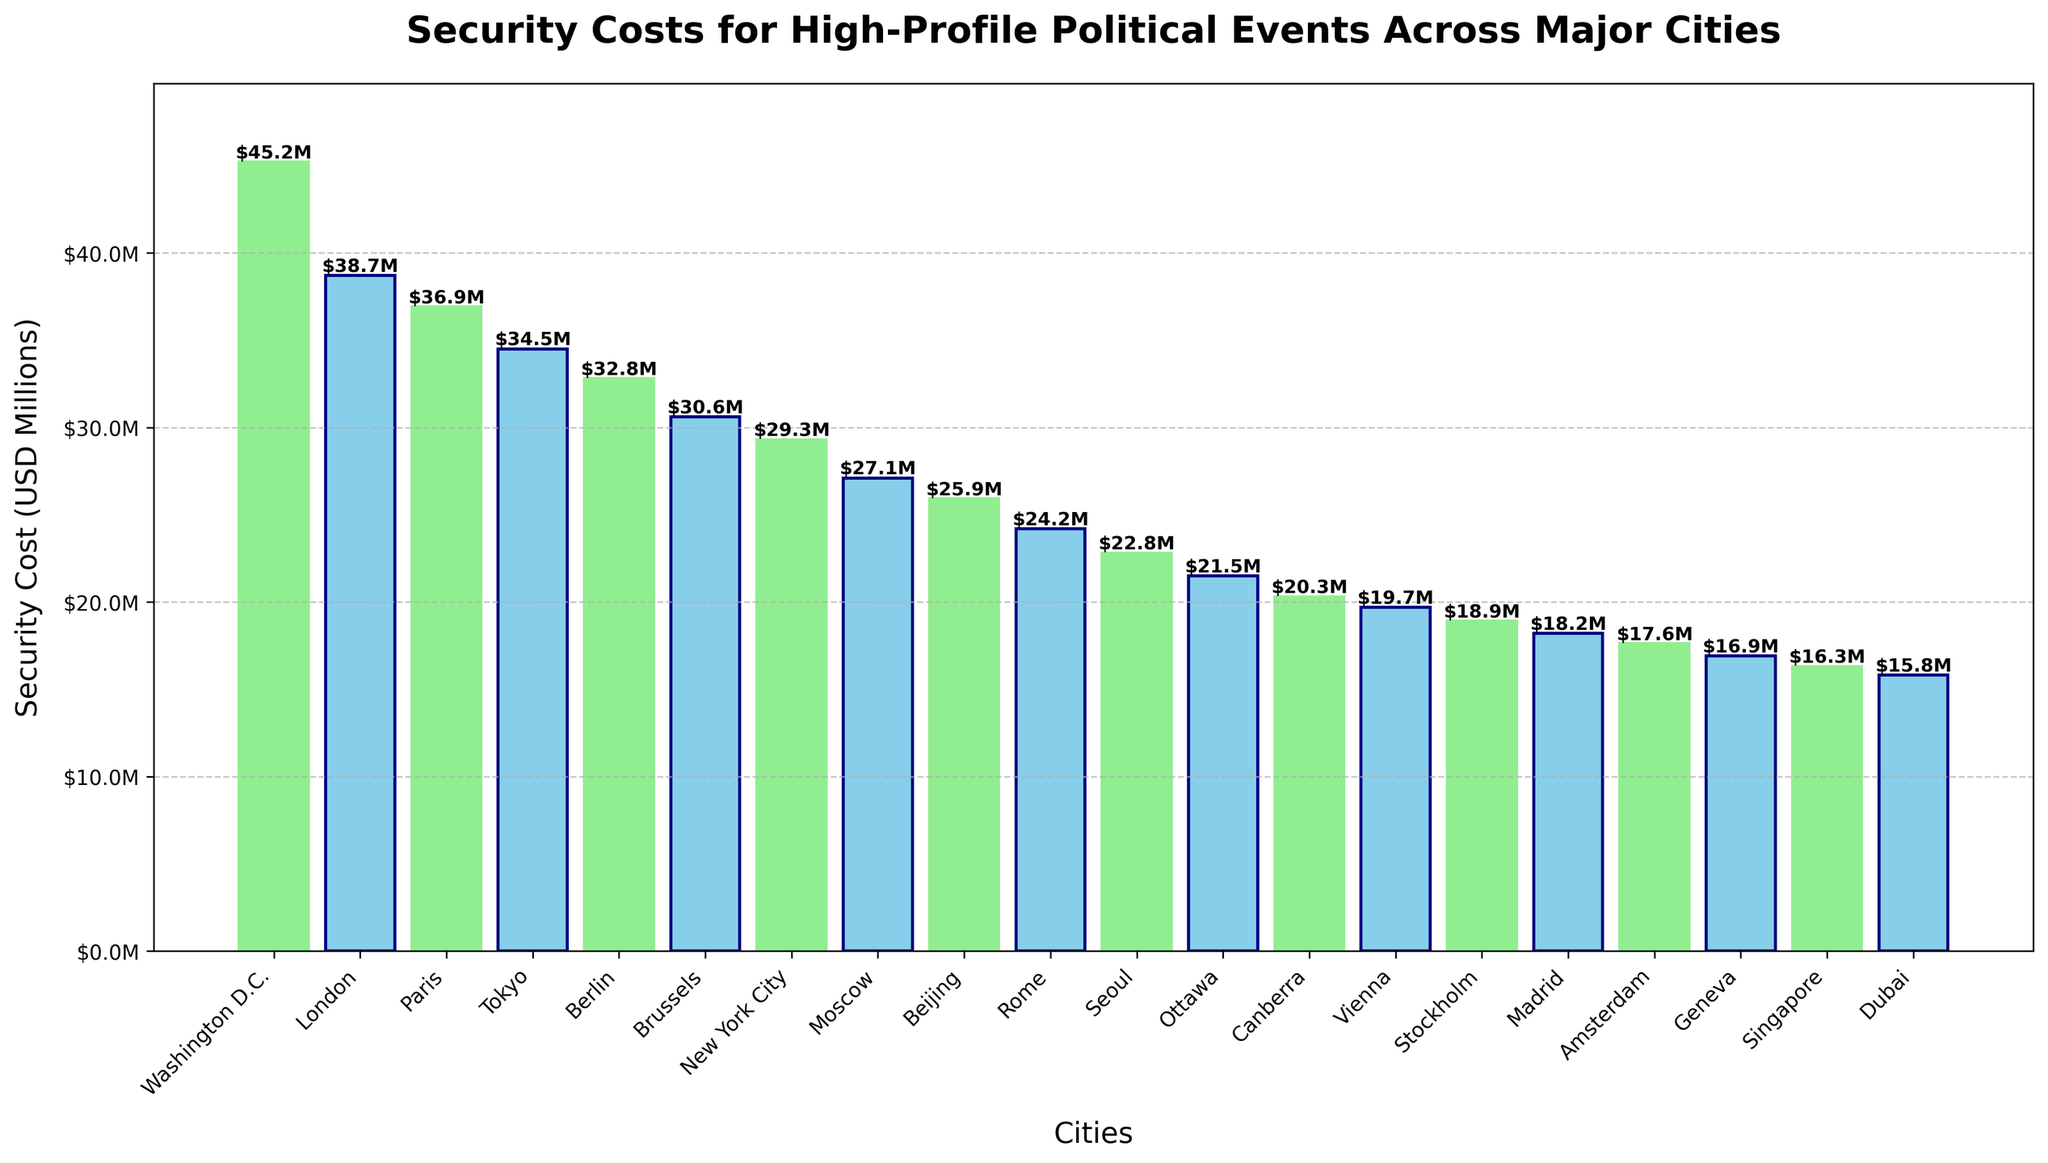What's the highest security cost among all cities? From the figure, identify the tallest bar, which represents Washington D.C. with a security cost of $45.2M.
Answer: $45.2M How much more is the security cost in Washington D.C. compared to the average cost of all cities? First, calculate the average security cost by summing all costs and dividing by the number of cities. Sum is $541.2M and the number of cities is 20, so average is $27.06M. The difference with Washington D.C.'s cost is $45.2M - $27.06M.
Answer: $18.14M Which city has the lowest security cost, and what is it? From the figure, find the shortest bar, which is for Dubai with a security cost of $15.8M.
Answer: Dubai, $15.8M What is the median security cost among the cities? To find the median, list all costs in ascending order and find the middle value. With 20 cities, the median is the average of the 10th and 11th values: ($22.8M + $24.2M)/2.
Answer: $23.5M How does the security cost in New York City compare to that in Tokyo? Look at the bars for New York City and Tokyo, noting their heights or labels. New York City's cost is $29.3M and Tokyo's is $34.5M, so Tokyo has the higher cost.
Answer: Tokyo is higher by $5.2M Which city has a security cost closest to the average cost of all cities? First, calculate the average as $27.06M. Then, identify the city with a cost closest to this value from the figure, which is Moscow with $27.1M.
Answer: Moscow What's the total security cost for Brussels, Berlin, and Paris combined? Look at the individual bars for these cities. Brussels is $30.6M, Berlin is $32.8M, and Paris is $36.9M. Sum these values: $30.6M + $32.8M + $36.9M.
Answer: $100.3M Is Amsterdam's security cost closer to Beijing's or Vienna's? Amsterdam's cost is $17.6M, Beijing's is $25.9M, and Vienna's is $19.7M. Calculate the differences: $25.9M - $17.6M and $19.7M - $17.6M to see which is smaller.
Answer: Vienna How much do the security costs for London and Paris differ, and which is higher? From the figure, London's cost is $38.7M and Paris's is $36.9M. The difference is $38.7M - $36.9M, with London being higher.
Answer: London, $1.8M What is the difference in security costs between the highest and lowest cost cities? Highest cost is Washington D.C. ($45.2M) and lowest is Dubai ($15.8M). Subtract the lowest from the highest: $45.2M - $15.8M.
Answer: $29.4M 